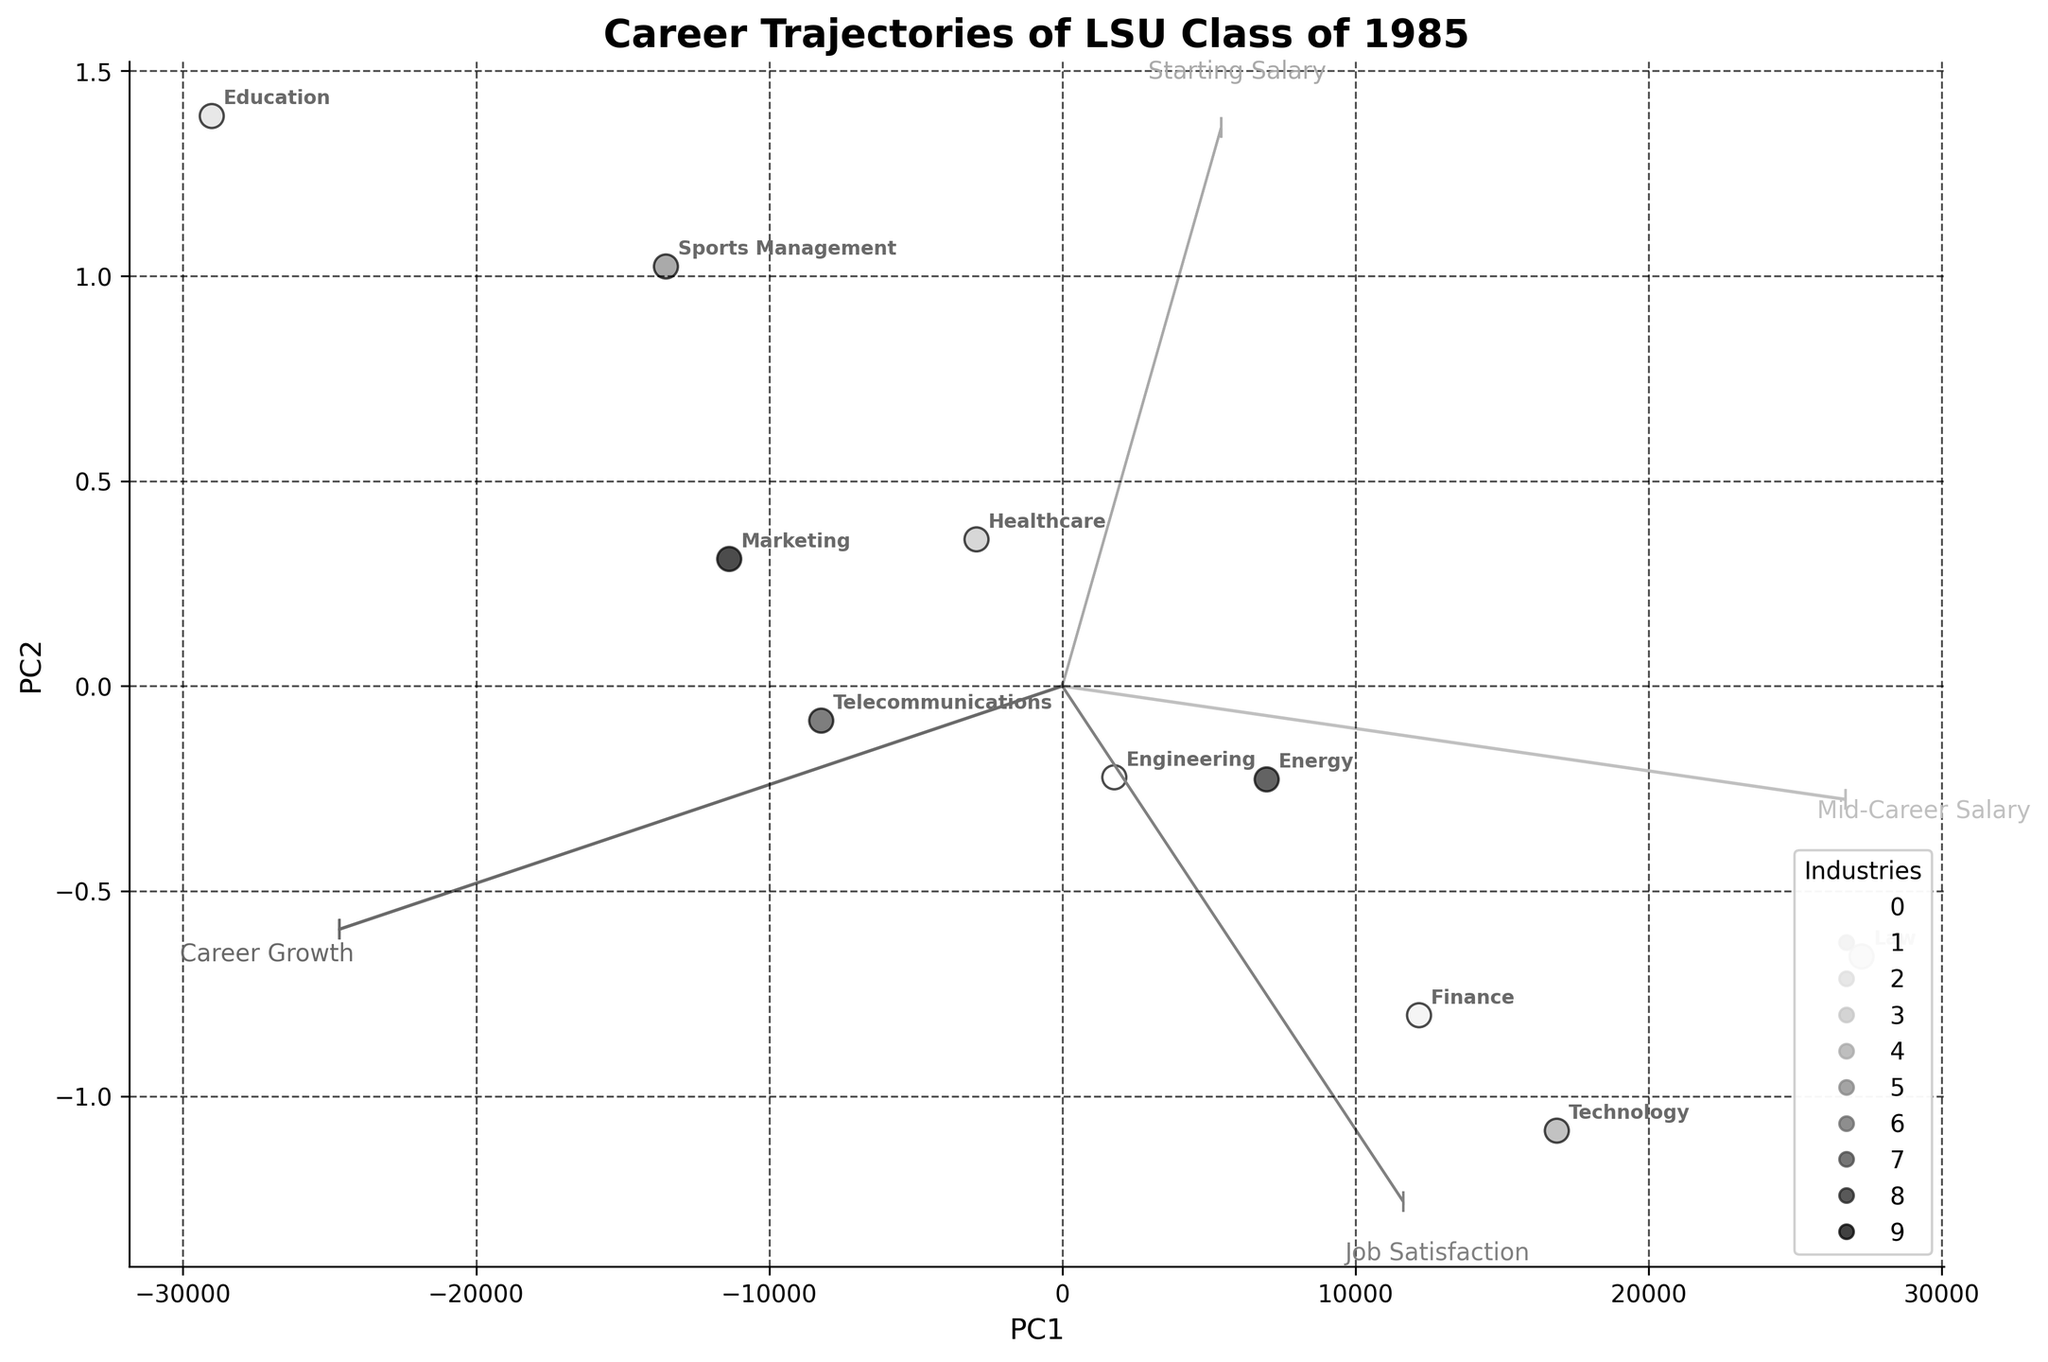1. What is the title of the plot? The title of the plot is displayed at the top center of the figure with bold and larger font size.
Answer: Career Trajectories of LSU Class of 1985 2. How many data points (industries) are represented in the scatter plot? The number of data points can be counted by observing the number of labels associated with the points in the scatter plot.
Answer: 10 3. Which industry has the highest mid-career salary? The figure plots average mid-career salaries along one of the PCA components. By identifying the point farthest along this axis and checking the label, we find the industry.
Answer: Law 4. Compare job satisfaction and career growth: Which industry shows the best balance? To determine the best balance, look for an industry that has high scores in both job satisfaction and career growth. Identifying and cross-referencing the data points on the respective PCA component reveals the best balanced industry.
Answer: Sports Management 5. Is any industry showing high starting salary but lower job satisfaction? Compare the starting salary PCA component with the job satisfaction PCA component. Identify the industries with high values in the former and relatively lower in the latter.
Answer: Law 6. Which vector is longer, the 'Starting Salary' or 'Mid-Career Salary'? By comparing the arrows representing the variable vectors, the relative length indicates which one is longer.
Answer: Mid-Career Salary 7. How do Education and Technology industries compare in terms of job satisfaction and career growth? By locating the positions of Education and Technology and observing their positions on the job satisfaction and career growth PCA dimensions, we can compare their relative values.
Answer: Education has higher job satisfaction but lower career growth compared to Technology 8. Which industries show greater spread in PC1 versus PC2? The spread in PC1 and PC2 can be assessed by comparing the relative dispersion of the data points along these two components.
Answer: PC1 9. Which industry is closest to the origin in the plot? The industry closest to the origin will have the smallest values along both PCA dimensions, indicating minimal deviation from the mean in all variables.
Answer: Telecommunications 10. Are there any industries which have both high starting and mid-career salaries but low job satisfaction? By locating industries with high values for both salary variables and then checking their job satisfaction positions on the PCA plot, we can identify any such industries.
Answer: Law 